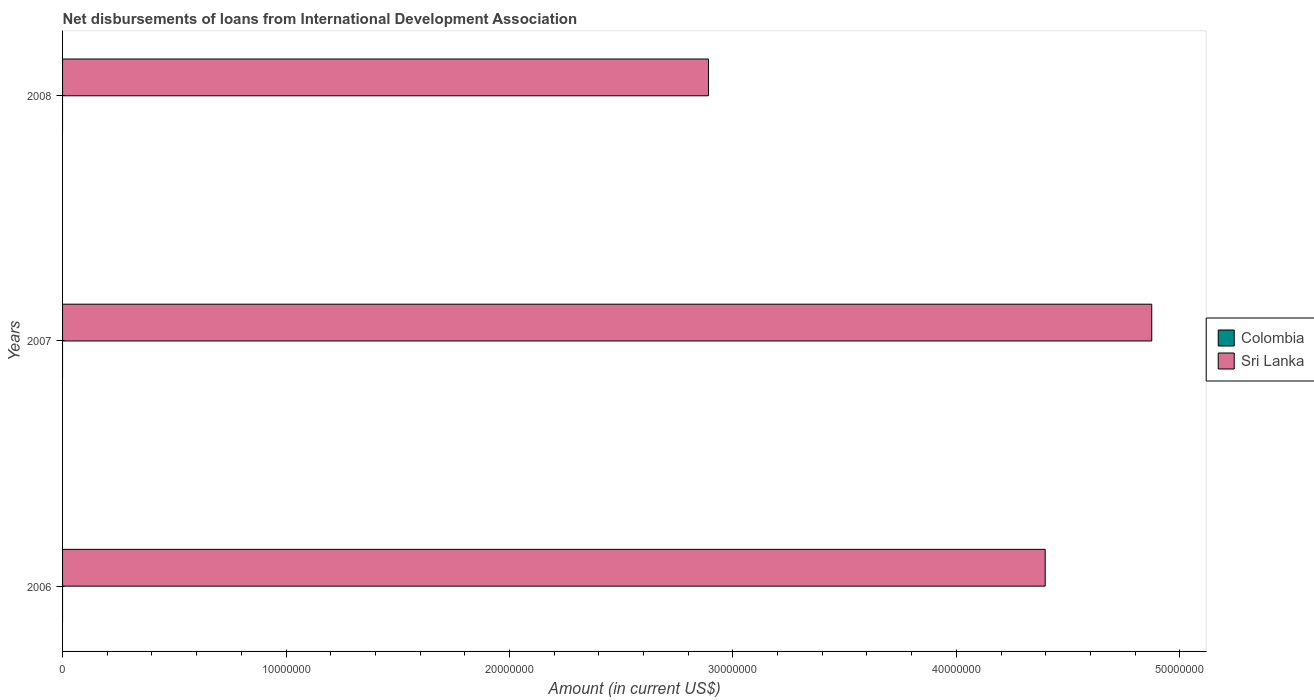Are the number of bars per tick equal to the number of legend labels?
Make the answer very short. No. How many bars are there on the 1st tick from the top?
Your answer should be very brief. 1. In how many cases, is the number of bars for a given year not equal to the number of legend labels?
Keep it short and to the point. 3. What is the amount of loans disbursed in Colombia in 2007?
Your answer should be very brief. 0. Across all years, what is the maximum amount of loans disbursed in Sri Lanka?
Provide a succinct answer. 4.87e+07. Across all years, what is the minimum amount of loans disbursed in Colombia?
Provide a succinct answer. 0. What is the difference between the amount of loans disbursed in Sri Lanka in 2007 and that in 2008?
Your response must be concise. 1.98e+07. What is the difference between the amount of loans disbursed in Sri Lanka in 2006 and the amount of loans disbursed in Colombia in 2007?
Ensure brevity in your answer.  4.40e+07. What is the average amount of loans disbursed in Sri Lanka per year?
Keep it short and to the point. 4.05e+07. In how many years, is the amount of loans disbursed in Colombia greater than 38000000 US$?
Offer a very short reply. 0. What is the ratio of the amount of loans disbursed in Sri Lanka in 2006 to that in 2007?
Your response must be concise. 0.9. What is the difference between the highest and the second highest amount of loans disbursed in Sri Lanka?
Give a very brief answer. 4.77e+06. What is the difference between the highest and the lowest amount of loans disbursed in Sri Lanka?
Give a very brief answer. 1.98e+07. How many bars are there?
Offer a very short reply. 3. How many years are there in the graph?
Give a very brief answer. 3. Does the graph contain any zero values?
Your answer should be very brief. Yes. Does the graph contain grids?
Make the answer very short. No. How are the legend labels stacked?
Your answer should be compact. Vertical. What is the title of the graph?
Offer a terse response. Net disbursements of loans from International Development Association. Does "Saudi Arabia" appear as one of the legend labels in the graph?
Ensure brevity in your answer.  No. What is the label or title of the X-axis?
Offer a very short reply. Amount (in current US$). What is the Amount (in current US$) in Colombia in 2006?
Your answer should be compact. 0. What is the Amount (in current US$) of Sri Lanka in 2006?
Provide a short and direct response. 4.40e+07. What is the Amount (in current US$) in Colombia in 2007?
Keep it short and to the point. 0. What is the Amount (in current US$) in Sri Lanka in 2007?
Provide a succinct answer. 4.87e+07. What is the Amount (in current US$) of Sri Lanka in 2008?
Offer a terse response. 2.89e+07. Across all years, what is the maximum Amount (in current US$) in Sri Lanka?
Give a very brief answer. 4.87e+07. Across all years, what is the minimum Amount (in current US$) in Sri Lanka?
Offer a very short reply. 2.89e+07. What is the total Amount (in current US$) in Colombia in the graph?
Your answer should be compact. 0. What is the total Amount (in current US$) in Sri Lanka in the graph?
Keep it short and to the point. 1.22e+08. What is the difference between the Amount (in current US$) of Sri Lanka in 2006 and that in 2007?
Your answer should be compact. -4.77e+06. What is the difference between the Amount (in current US$) in Sri Lanka in 2006 and that in 2008?
Your answer should be very brief. 1.51e+07. What is the difference between the Amount (in current US$) in Sri Lanka in 2007 and that in 2008?
Offer a very short reply. 1.98e+07. What is the average Amount (in current US$) in Sri Lanka per year?
Provide a succinct answer. 4.05e+07. What is the ratio of the Amount (in current US$) of Sri Lanka in 2006 to that in 2007?
Give a very brief answer. 0.9. What is the ratio of the Amount (in current US$) of Sri Lanka in 2006 to that in 2008?
Provide a succinct answer. 1.52. What is the ratio of the Amount (in current US$) in Sri Lanka in 2007 to that in 2008?
Your answer should be compact. 1.69. What is the difference between the highest and the second highest Amount (in current US$) of Sri Lanka?
Your response must be concise. 4.77e+06. What is the difference between the highest and the lowest Amount (in current US$) in Sri Lanka?
Your answer should be very brief. 1.98e+07. 